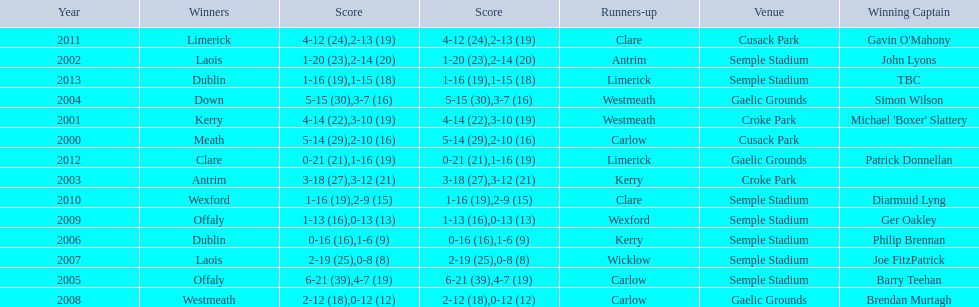Who scored the least? Wicklow. 